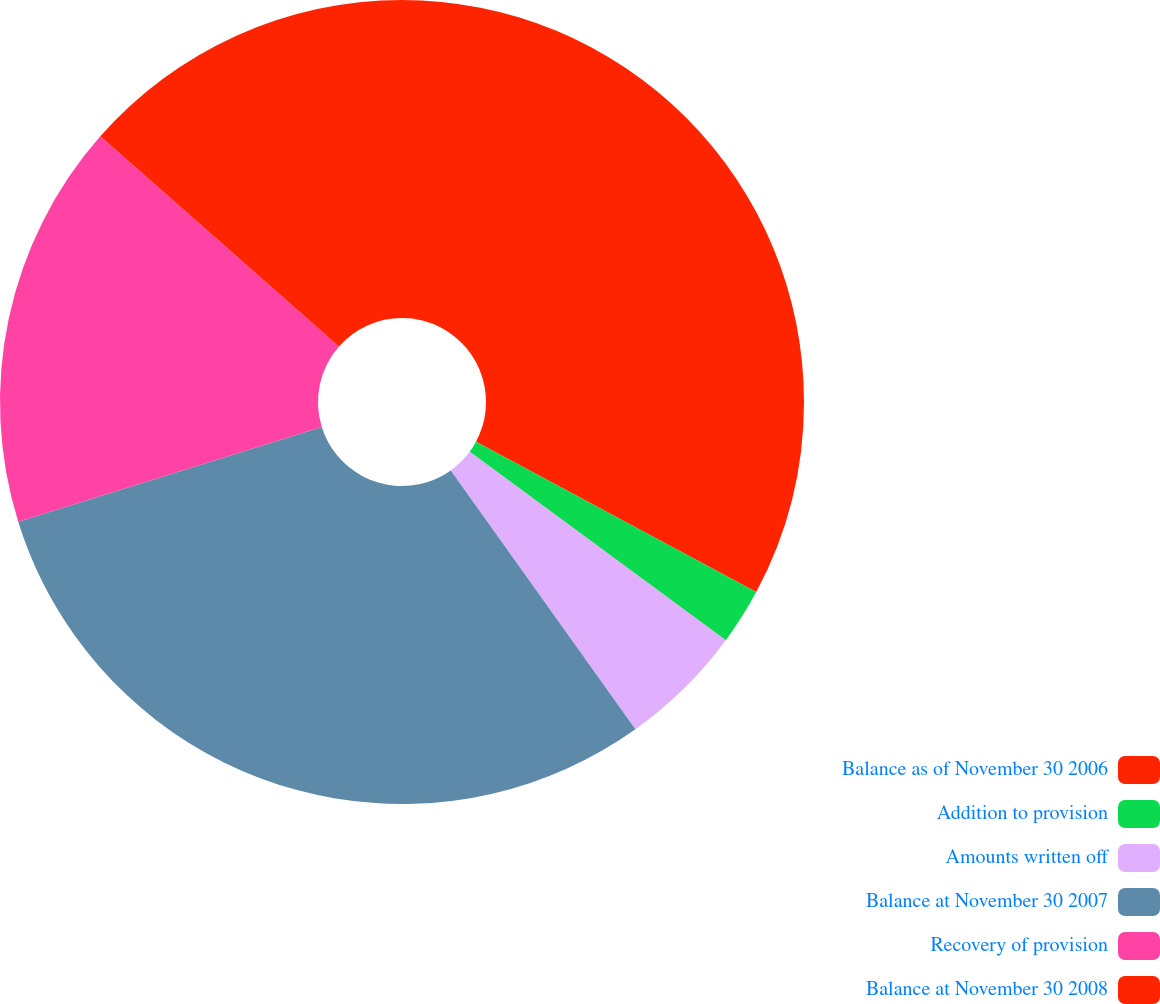<chart> <loc_0><loc_0><loc_500><loc_500><pie_chart><fcel>Balance as of November 30 2006<fcel>Addition to provision<fcel>Amounts written off<fcel>Balance at November 30 2007<fcel>Recovery of provision<fcel>Balance at November 30 2008<nl><fcel>32.84%<fcel>2.26%<fcel>5.04%<fcel>30.05%<fcel>16.3%<fcel>13.51%<nl></chart> 